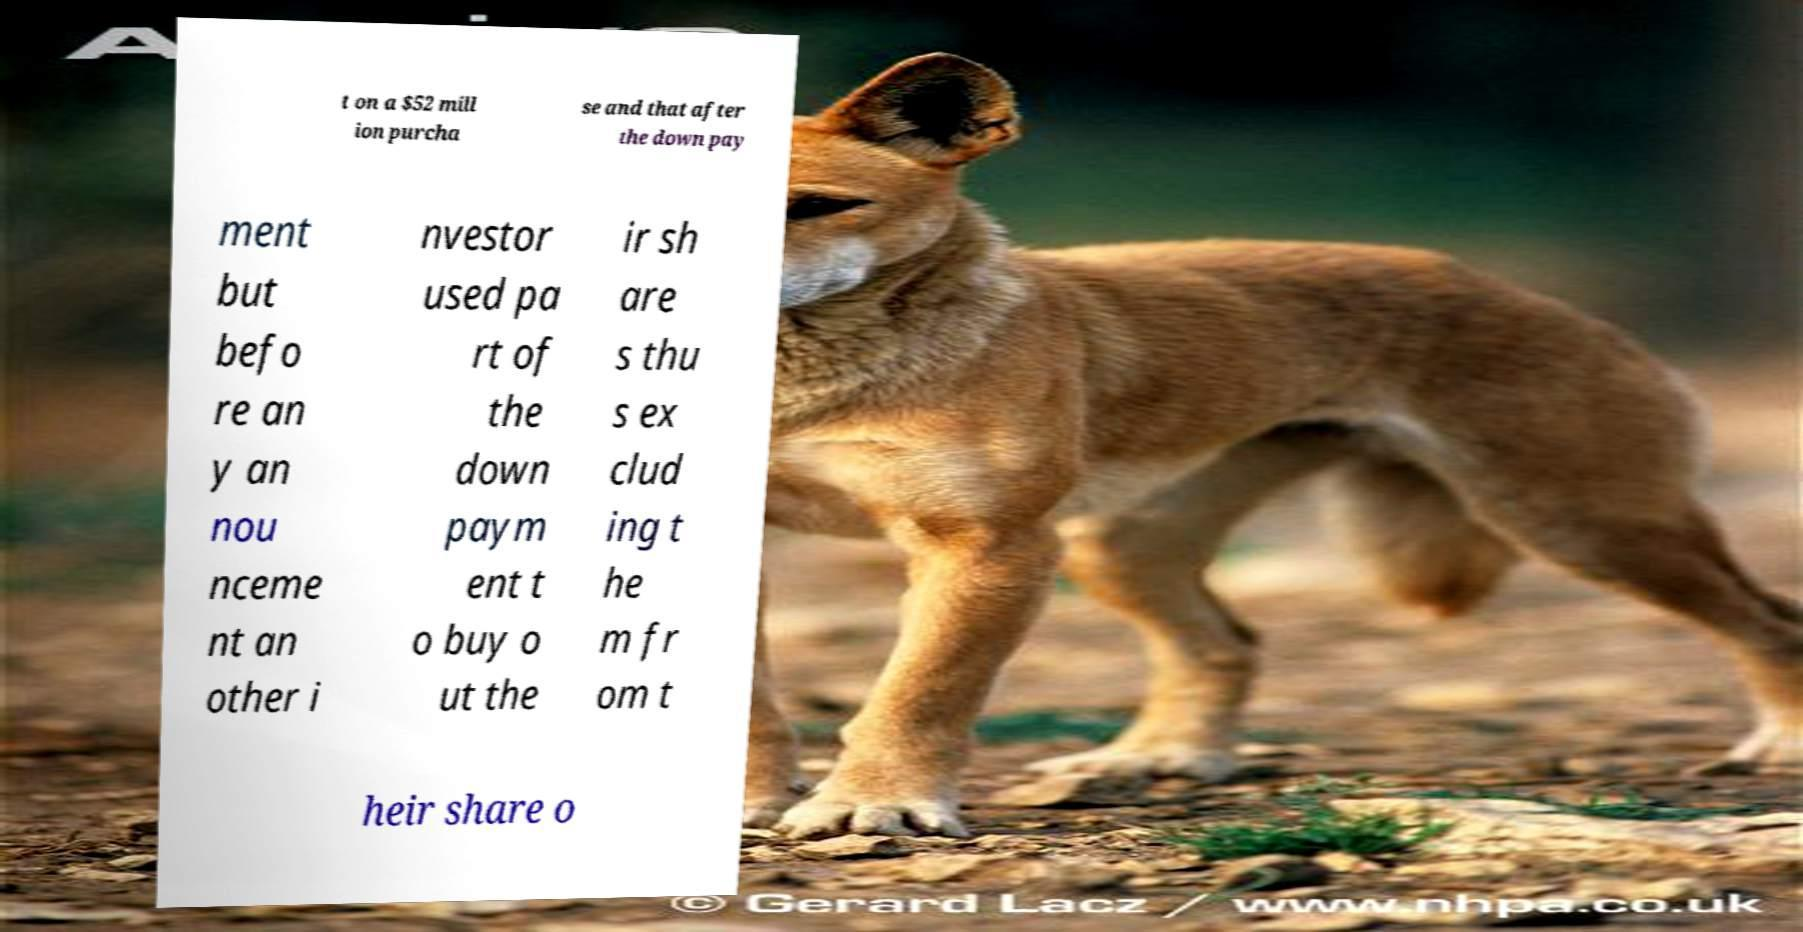Can you accurately transcribe the text from the provided image for me? t on a $52 mill ion purcha se and that after the down pay ment but befo re an y an nou nceme nt an other i nvestor used pa rt of the down paym ent t o buy o ut the ir sh are s thu s ex clud ing t he m fr om t heir share o 